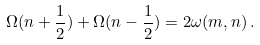<formula> <loc_0><loc_0><loc_500><loc_500>\Omega ( n + \frac { 1 } { 2 } ) + \Omega ( n - \frac { 1 } { 2 } ) = 2 \omega ( m , n ) \, .</formula> 